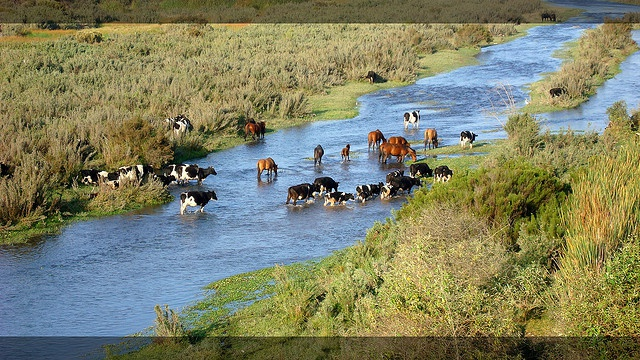Describe the objects in this image and their specific colors. I can see cow in olive, black, and gray tones, cow in olive, black, beige, gray, and darkgray tones, cow in olive, black, tan, khaki, and beige tones, cow in olive, black, beige, and gray tones, and horse in olive, maroon, brown, and black tones in this image. 